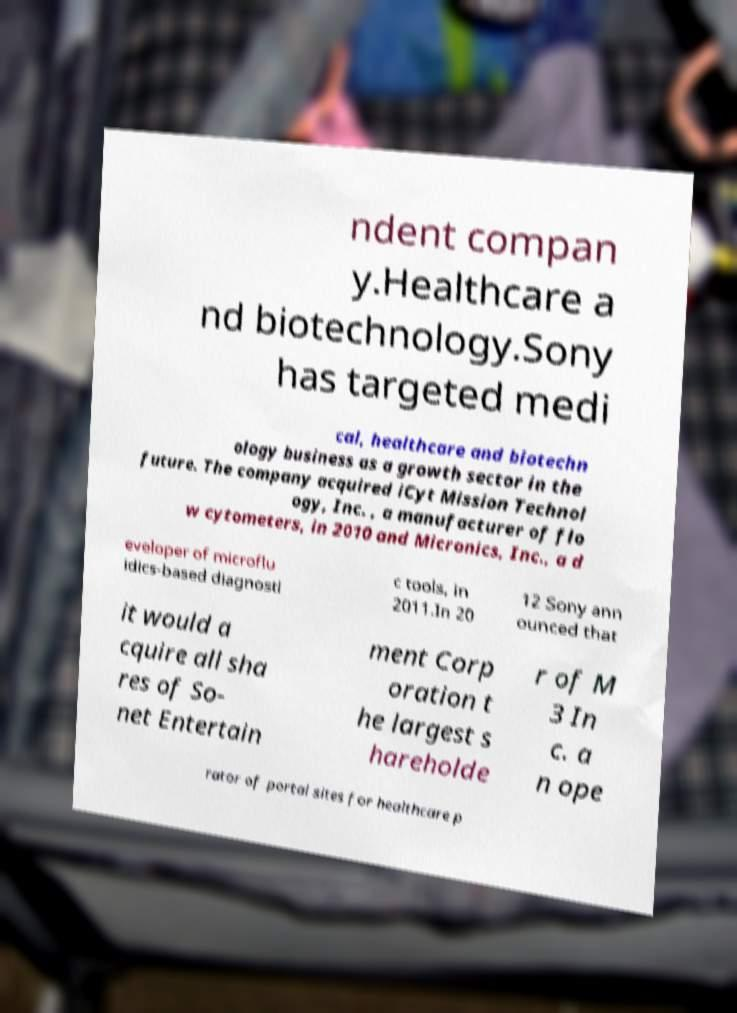There's text embedded in this image that I need extracted. Can you transcribe it verbatim? ndent compan y.Healthcare a nd biotechnology.Sony has targeted medi cal, healthcare and biotechn ology business as a growth sector in the future. The company acquired iCyt Mission Technol ogy, Inc. , a manufacturer of flo w cytometers, in 2010 and Micronics, Inc., a d eveloper of microflu idics-based diagnosti c tools, in 2011.In 20 12 Sony ann ounced that it would a cquire all sha res of So- net Entertain ment Corp oration t he largest s hareholde r of M 3 In c. a n ope rator of portal sites for healthcare p 